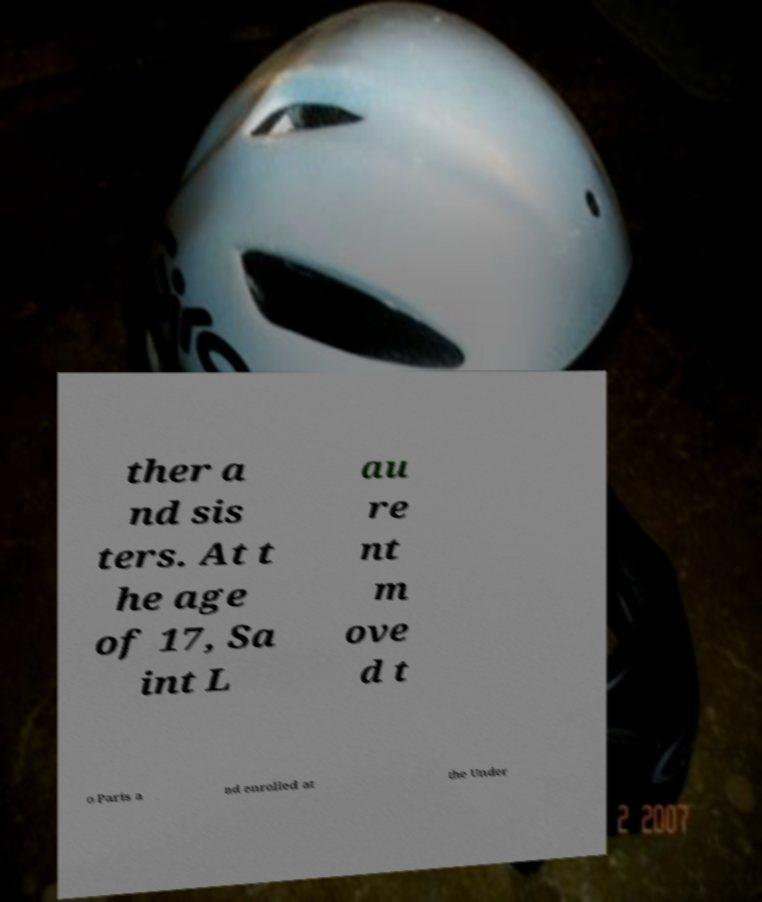Could you extract and type out the text from this image? ther a nd sis ters. At t he age of 17, Sa int L au re nt m ove d t o Paris a nd enrolled at the Under 